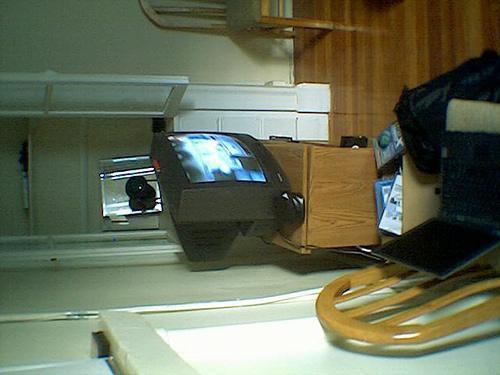How many chairs are there?
Give a very brief answer. 2. How many red cars are there?
Give a very brief answer. 0. 